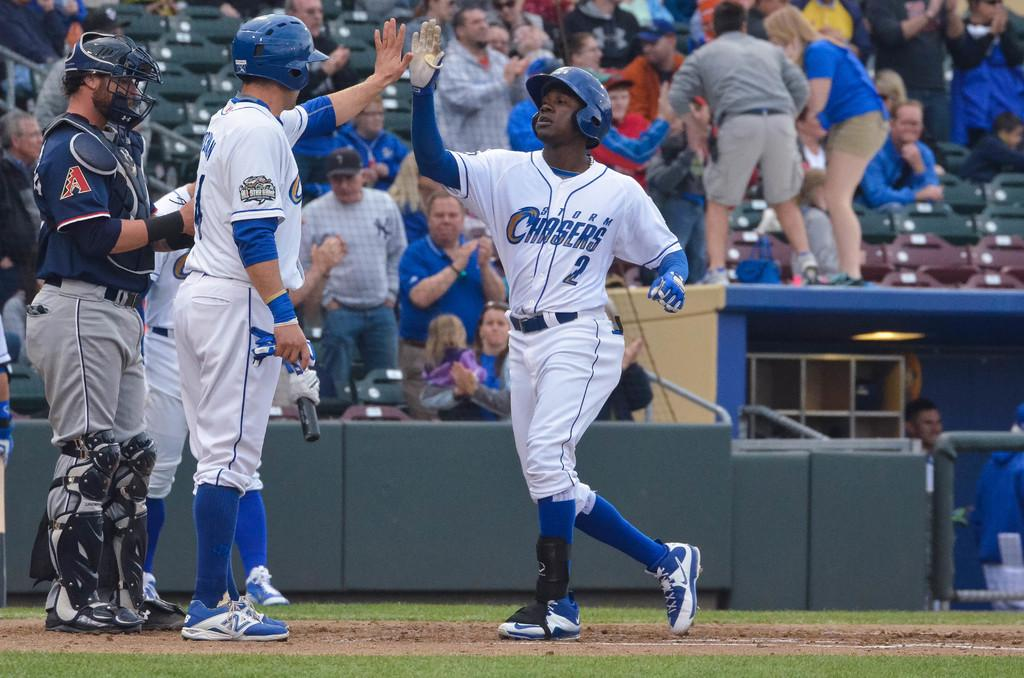<image>
Render a clear and concise summary of the photo. Storm Chasers baseball player #2 high fives a teammate in a crowded stadium. 